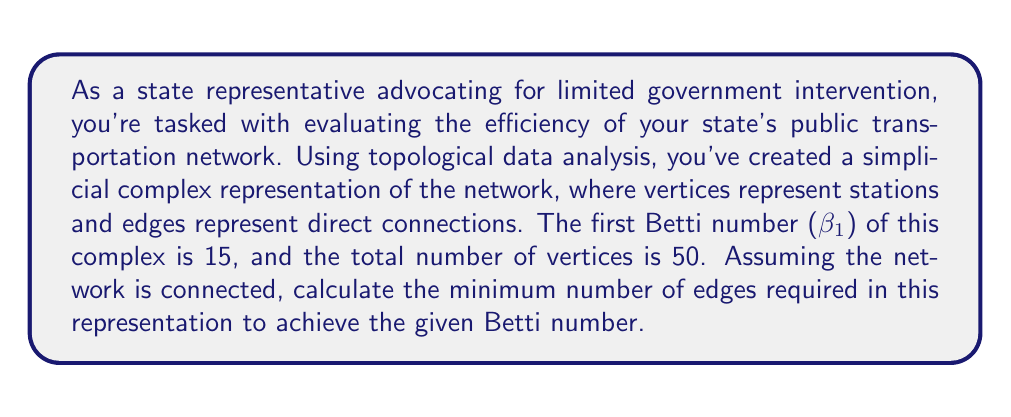Can you answer this question? To solve this problem, we need to understand the relationship between the Betti numbers, the number of vertices, and the number of edges in a simplicial complex. We'll use the following steps:

1) Recall that for a 1-dimensional simplicial complex (which our network representation is), the first Betti number $\beta_1$ represents the number of cycles or loops in the complex.

2) The Euler characteristic $\chi$ of a simplicial complex is given by:

   $$\chi = V - E + F$$

   where V is the number of vertices, E is the number of edges, and F is the number of faces (which is 0 in our 1-dimensional case).

3) For a connected 1-dimensional simplicial complex, the Euler characteristic is related to the first Betti number by:

   $$\chi = 1 - \beta_1$$

4) Substituting the Euler characteristic formula and solving for E:

   $$1 - \beta_1 = V - E$$
   $$E = V + \beta_1 - 1$$

5) We're given that $V = 50$ and $\beta_1 = 15$. Let's substitute these values:

   $$E = 50 + 15 - 1 = 64$$

Therefore, the minimum number of edges required to achieve the given Betti number is 64.

This approach allows us to evaluate the network's complexity while focusing on its essential topological features, aligning with a limited government intervention perspective by providing an efficient assessment method.
Answer: 64 edges 